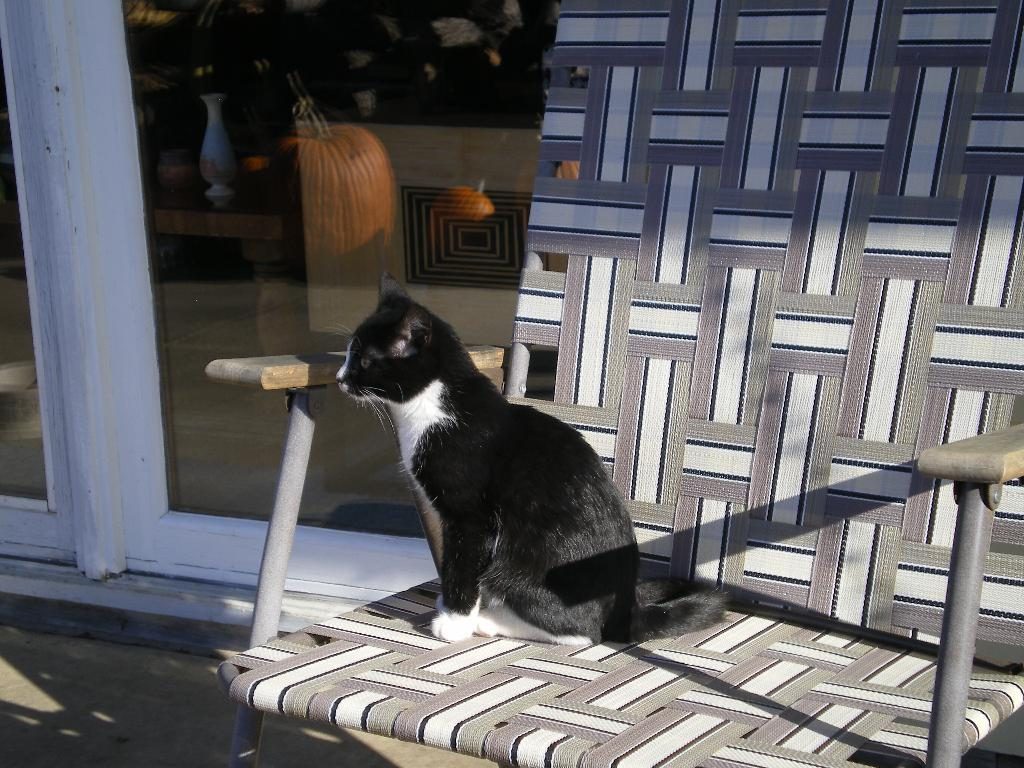What type of animal is in the image? There is a black and white cat in the image. Where is the cat sitting? The cat is sitting on a chair. What type of doors can be seen in the image? There is a glass door and a wooden door in the image. What color are the doors? Both the glass door and the wooden door are white in color. What type of shelf can be seen in the image? There is no shelf present in the image. Can you describe the cat's reaction to the sudden smash in the image? There is no smash or any indication of a sudden event in the image. 